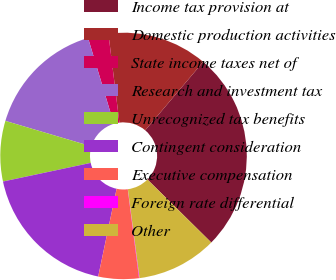Convert chart. <chart><loc_0><loc_0><loc_500><loc_500><pie_chart><fcel>Income tax provision at<fcel>Domestic production activities<fcel>State income taxes net of<fcel>Research and investment tax<fcel>Unrecognized tax benefits<fcel>Contingent consideration<fcel>Executive compensation<fcel>Foreign rate differential<fcel>Other<nl><fcel>26.21%<fcel>13.14%<fcel>2.69%<fcel>15.76%<fcel>7.92%<fcel>18.37%<fcel>5.3%<fcel>0.07%<fcel>10.53%<nl></chart> 